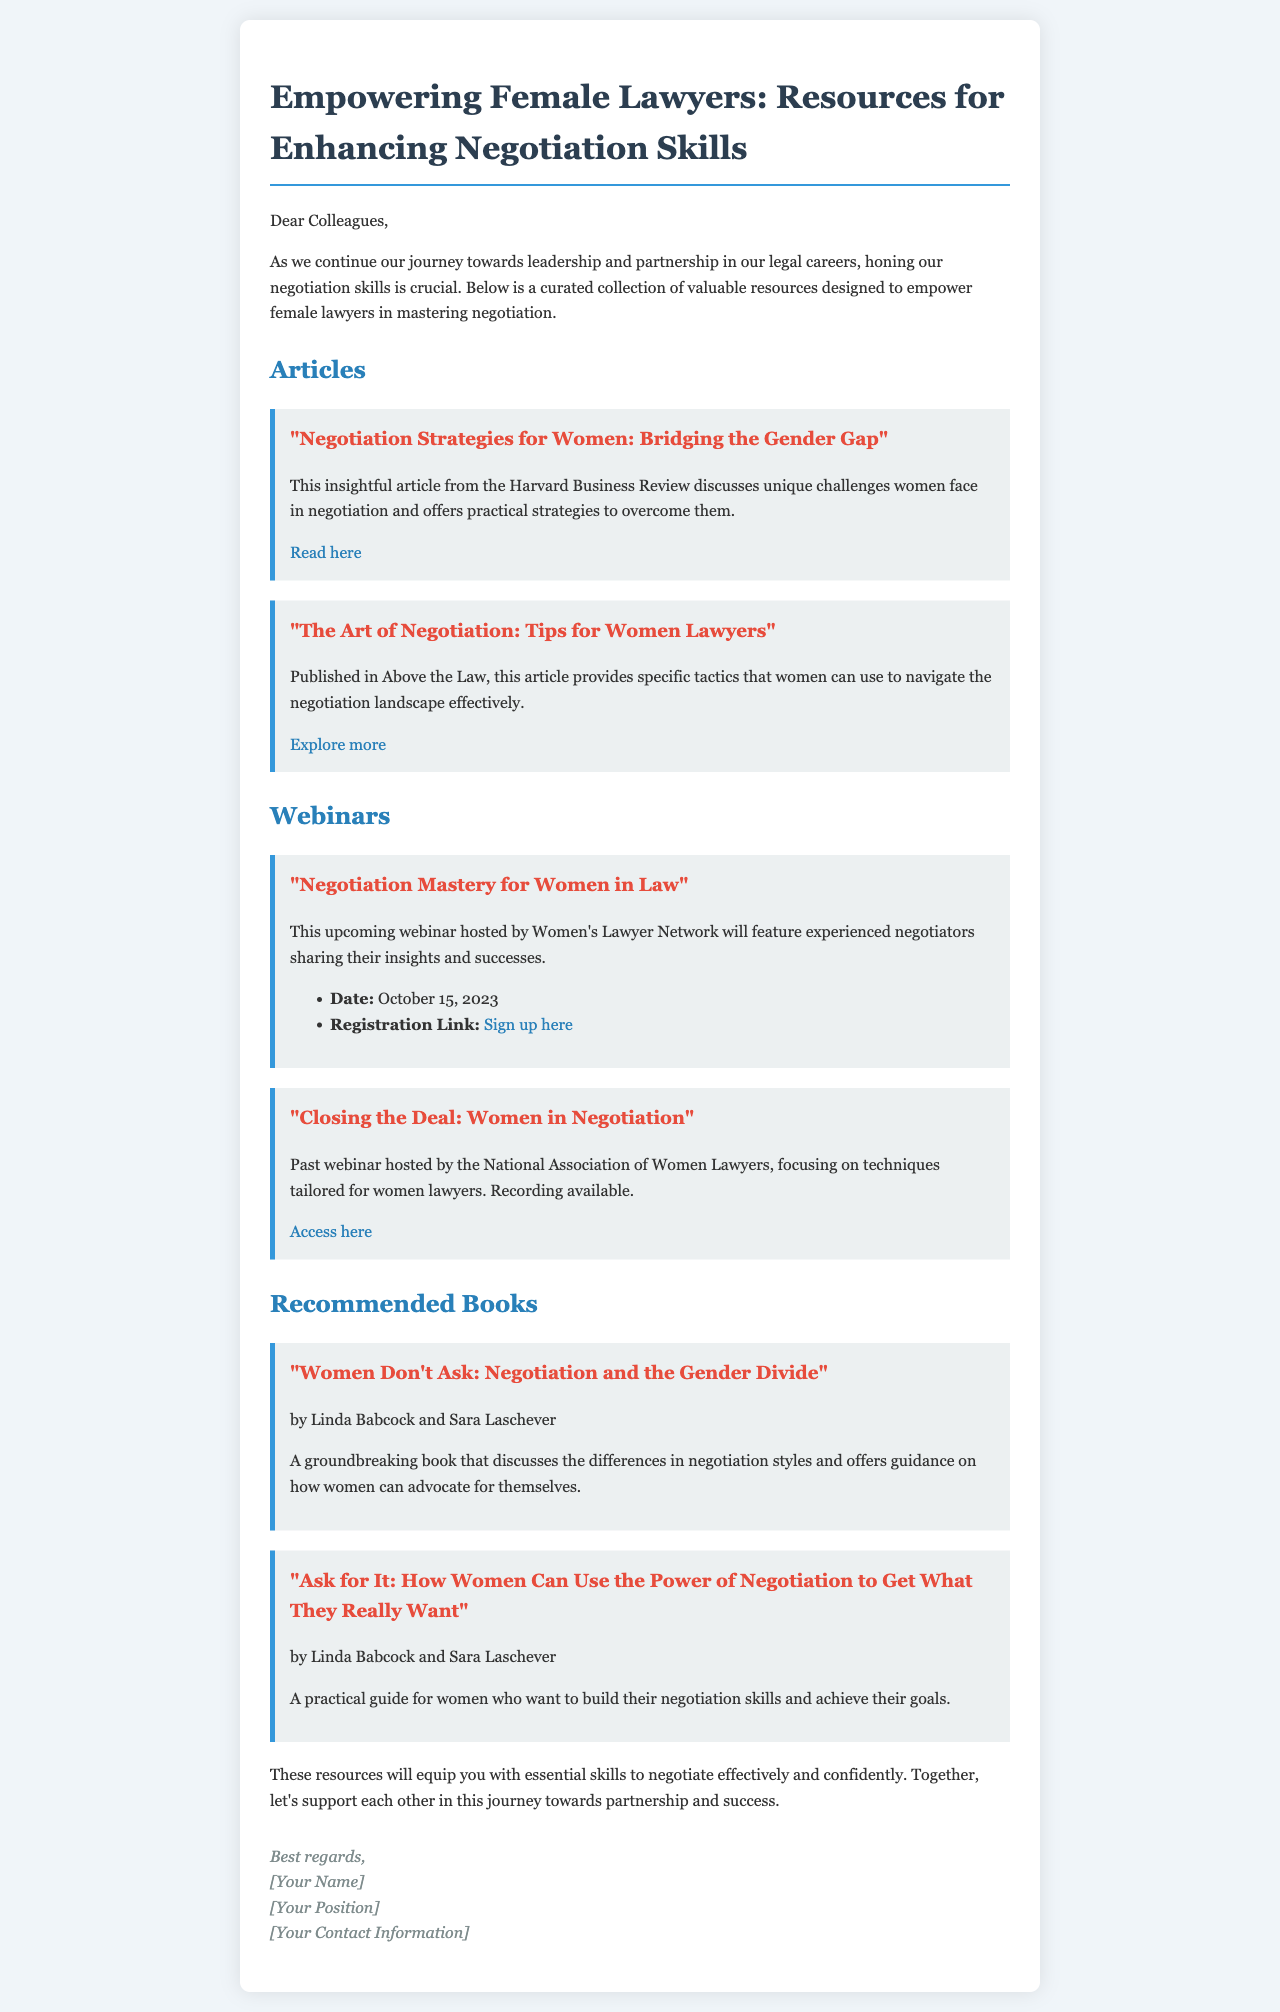What is the title of the email? The title of the email is found at the top of the document and provides the main subject.
Answer: Empowering Female Lawyers: Resources for Enhancing Negotiation Skills What organization is hosting the upcoming webinar? The hosting organization is mentioned in the description of the webinar section.
Answer: Women's Lawyer Network What is the date of the "Negotiation Mastery for Women in Law" webinar? The date is specifically stated in the details of the webinar resource.
Answer: October 15, 2023 Who are the authors of the book "Women Don't Ask"? The book's authors are listed in the recommended books section.
Answer: Linda Babcock and Sara Laschever What type of resources are included in the document? The different sections outlined in the email indicate the types of resources available.
Answer: Articles, webinars, recommended books What color is the text in the header of the document? The heading color is stated in the style section, describing the design choices.
Answer: #2c3e50 What was the focus of the past webinar by the National Association of Women Lawyers? The focus is detailed in the description of the past webinar resource.
Answer: Techniques tailored for women lawyers What is the overall aim of the resources listed in the document? The email provides a summary of the purpose at the beginning of the message.
Answer: To empower female lawyers in mastering negotiation 